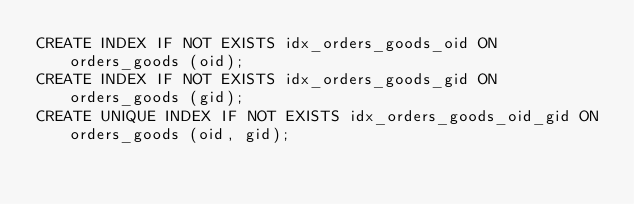<code> <loc_0><loc_0><loc_500><loc_500><_SQL_>CREATE INDEX IF NOT EXISTS idx_orders_goods_oid ON orders_goods (oid);
CREATE INDEX IF NOT EXISTS idx_orders_goods_gid ON orders_goods (gid);
CREATE UNIQUE INDEX IF NOT EXISTS idx_orders_goods_oid_gid ON orders_goods (oid, gid);

</code> 